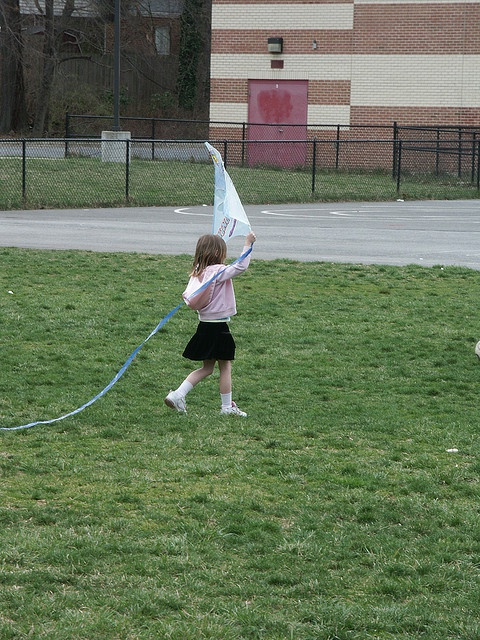Describe the objects in this image and their specific colors. I can see people in black, gray, darkgray, and darkgreen tones and kite in black, lightgray, lightblue, and darkgray tones in this image. 